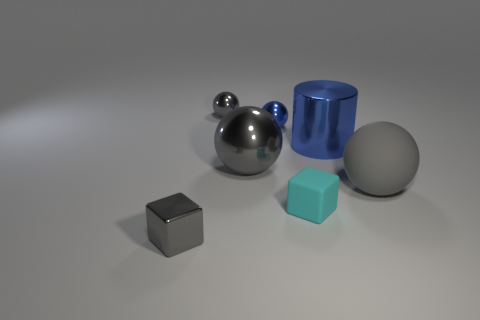Subtract all gray spheres. How many were subtracted if there are1gray spheres left? 2 Subtract all blue cubes. How many gray spheres are left? 3 Subtract 1 balls. How many balls are left? 3 Subtract all rubber spheres. How many spheres are left? 3 Subtract all purple spheres. Subtract all brown cylinders. How many spheres are left? 4 Add 2 gray metallic balls. How many objects exist? 9 Subtract all spheres. How many objects are left? 3 Add 1 gray metallic cubes. How many gray metallic cubes exist? 2 Subtract 0 cyan cylinders. How many objects are left? 7 Subtract all small metal cubes. Subtract all tiny red rubber spheres. How many objects are left? 6 